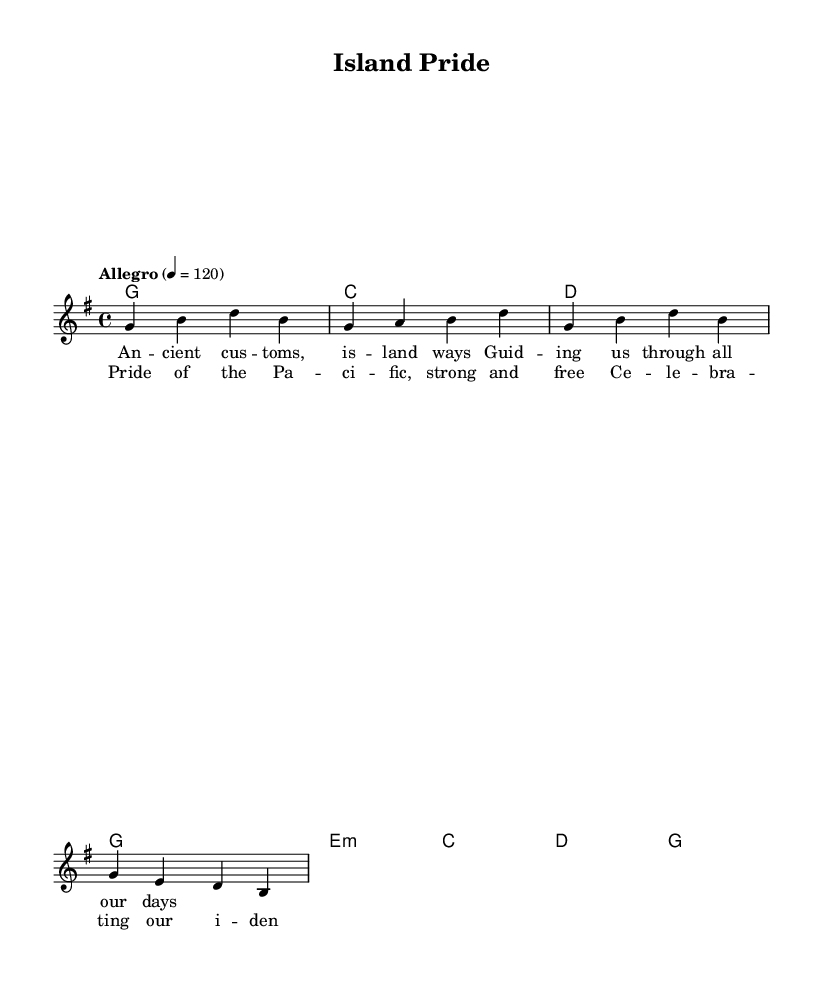What is the key signature of this music? The key signature is G major, which contains one sharp (F#).
Answer: G major What is the time signature of this piece? The time signature is 4/4, indicating there are four beats per measure.
Answer: 4/4 What is the tempo marking for this piece? The tempo marking is "Allegro," which indicates a fast, lively pace.
Answer: Allegro How many measures are in the melody? The melody consists of four measures, with each line having two measures.
Answer: Four What chords are used in the chorus? The chorus uses G, C, D chords, which are typical for country rock music, maintaining a strong harmonic foundation.
Answer: G, C, D How does the melody outline the lyrics? The melody aligns with the lyrics, using syllables that match the rhythm and emphasizing the important words. This creates a cohesive musical and lyrical narrative.
Answer: Matches rhythmically What is the main theme of the lyrics? The main theme celebrates cultural identity and pride in Pacific Islander customs, supporting the upbeat nature of the music.
Answer: Cultural pride 